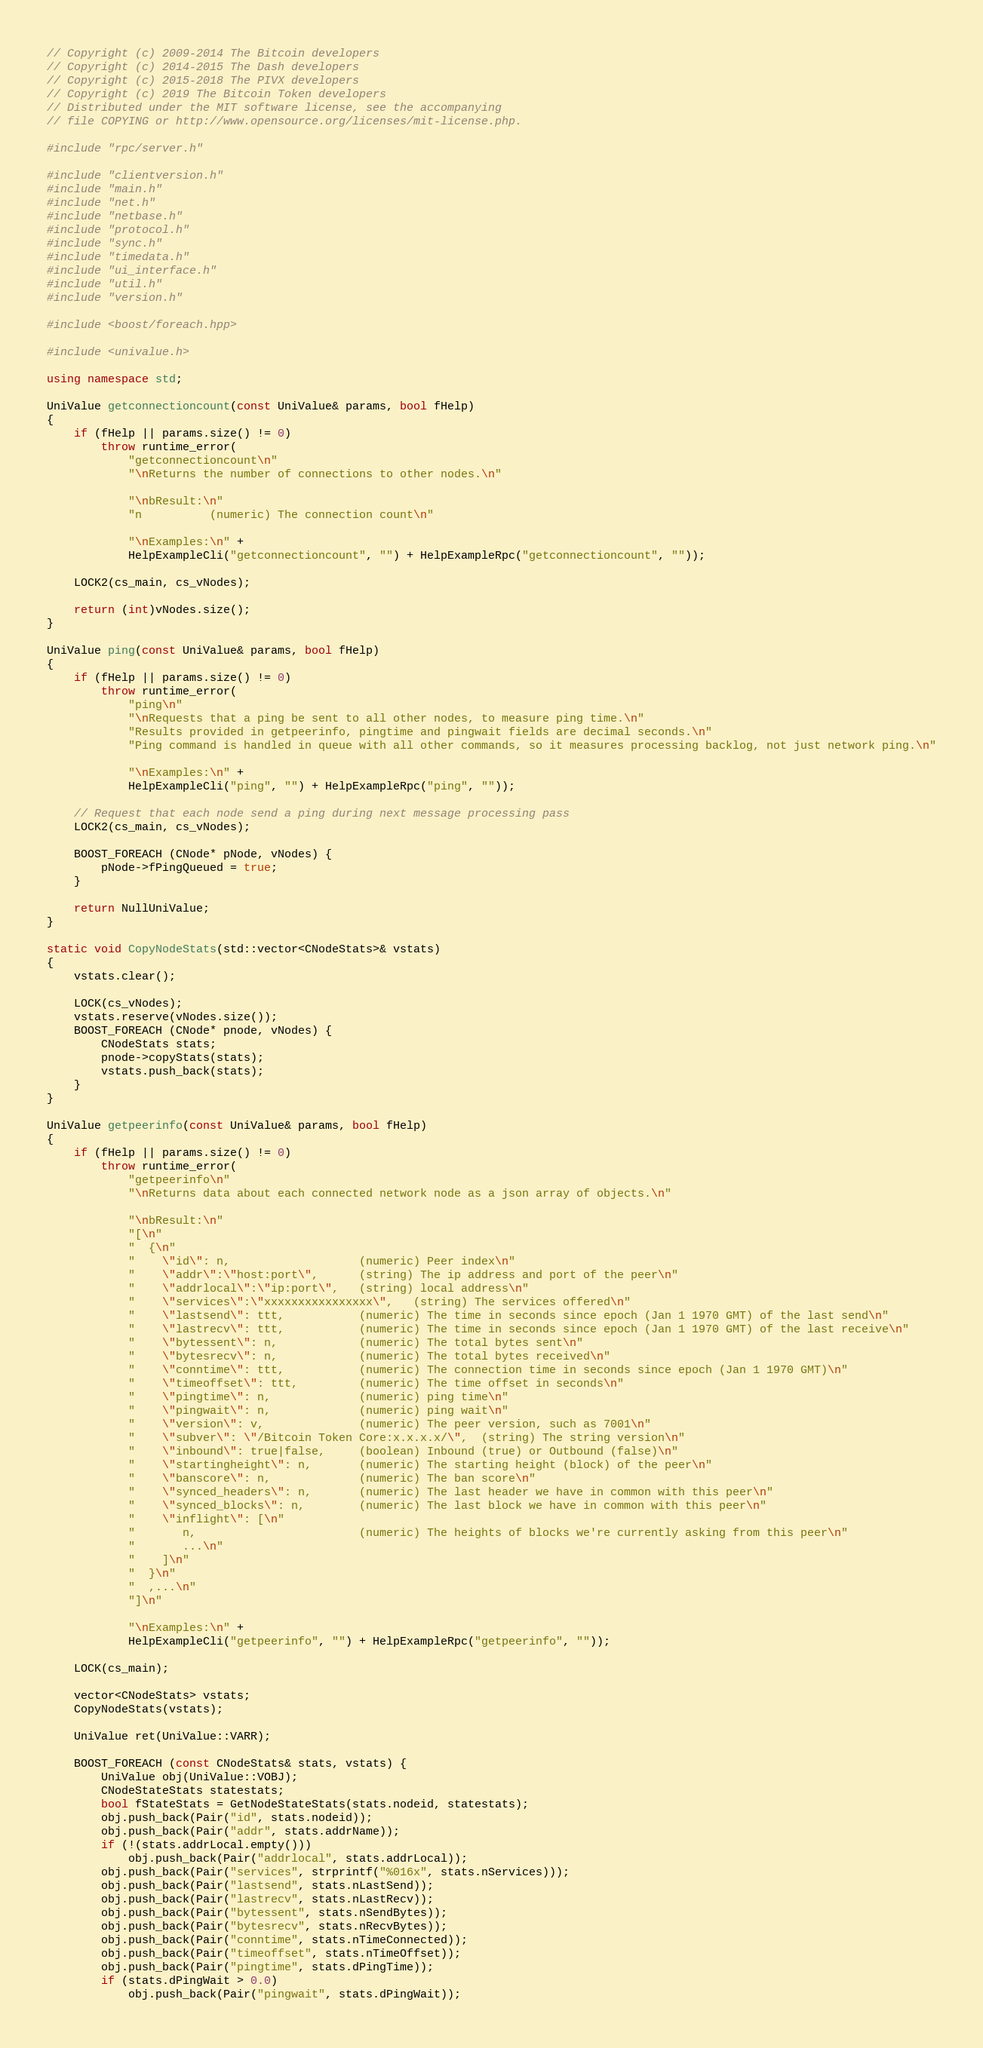Convert code to text. <code><loc_0><loc_0><loc_500><loc_500><_C++_>// Copyright (c) 2009-2014 The Bitcoin developers
// Copyright (c) 2014-2015 The Dash developers
// Copyright (c) 2015-2018 The PIVX developers
// Copyright (c) 2019 The Bitcoin Token developers
// Distributed under the MIT software license, see the accompanying
// file COPYING or http://www.opensource.org/licenses/mit-license.php.

#include "rpc/server.h"

#include "clientversion.h"
#include "main.h"
#include "net.h"
#include "netbase.h"
#include "protocol.h"
#include "sync.h"
#include "timedata.h"
#include "ui_interface.h"
#include "util.h"
#include "version.h"

#include <boost/foreach.hpp>

#include <univalue.h>

using namespace std;

UniValue getconnectioncount(const UniValue& params, bool fHelp)
{
    if (fHelp || params.size() != 0)
        throw runtime_error(
            "getconnectioncount\n"
            "\nReturns the number of connections to other nodes.\n"

            "\nbResult:\n"
            "n          (numeric) The connection count\n"

            "\nExamples:\n" +
            HelpExampleCli("getconnectioncount", "") + HelpExampleRpc("getconnectioncount", ""));

    LOCK2(cs_main, cs_vNodes);

    return (int)vNodes.size();
}

UniValue ping(const UniValue& params, bool fHelp)
{
    if (fHelp || params.size() != 0)
        throw runtime_error(
            "ping\n"
            "\nRequests that a ping be sent to all other nodes, to measure ping time.\n"
            "Results provided in getpeerinfo, pingtime and pingwait fields are decimal seconds.\n"
            "Ping command is handled in queue with all other commands, so it measures processing backlog, not just network ping.\n"

            "\nExamples:\n" +
            HelpExampleCli("ping", "") + HelpExampleRpc("ping", ""));

    // Request that each node send a ping during next message processing pass
    LOCK2(cs_main, cs_vNodes);

    BOOST_FOREACH (CNode* pNode, vNodes) {
        pNode->fPingQueued = true;
    }

    return NullUniValue;
}

static void CopyNodeStats(std::vector<CNodeStats>& vstats)
{
    vstats.clear();

    LOCK(cs_vNodes);
    vstats.reserve(vNodes.size());
    BOOST_FOREACH (CNode* pnode, vNodes) {
        CNodeStats stats;
        pnode->copyStats(stats);
        vstats.push_back(stats);
    }
}

UniValue getpeerinfo(const UniValue& params, bool fHelp)
{
    if (fHelp || params.size() != 0)
        throw runtime_error(
            "getpeerinfo\n"
            "\nReturns data about each connected network node as a json array of objects.\n"

            "\nbResult:\n"
            "[\n"
            "  {\n"
            "    \"id\": n,                   (numeric) Peer index\n"
            "    \"addr\":\"host:port\",      (string) The ip address and port of the peer\n"
            "    \"addrlocal\":\"ip:port\",   (string) local address\n"
            "    \"services\":\"xxxxxxxxxxxxxxxx\",   (string) The services offered\n"
            "    \"lastsend\": ttt,           (numeric) The time in seconds since epoch (Jan 1 1970 GMT) of the last send\n"
            "    \"lastrecv\": ttt,           (numeric) The time in seconds since epoch (Jan 1 1970 GMT) of the last receive\n"
            "    \"bytessent\": n,            (numeric) The total bytes sent\n"
            "    \"bytesrecv\": n,            (numeric) The total bytes received\n"
            "    \"conntime\": ttt,           (numeric) The connection time in seconds since epoch (Jan 1 1970 GMT)\n"
            "    \"timeoffset\": ttt,         (numeric) The time offset in seconds\n"
            "    \"pingtime\": n,             (numeric) ping time\n"
            "    \"pingwait\": n,             (numeric) ping wait\n"
            "    \"version\": v,              (numeric) The peer version, such as 7001\n"
            "    \"subver\": \"/Bitcoin Token Core:x.x.x.x/\",  (string) The string version\n"
            "    \"inbound\": true|false,     (boolean) Inbound (true) or Outbound (false)\n"
            "    \"startingheight\": n,       (numeric) The starting height (block) of the peer\n"
            "    \"banscore\": n,             (numeric) The ban score\n"
            "    \"synced_headers\": n,       (numeric) The last header we have in common with this peer\n"
            "    \"synced_blocks\": n,        (numeric) The last block we have in common with this peer\n"
            "    \"inflight\": [\n"
            "       n,                        (numeric) The heights of blocks we're currently asking from this peer\n"
            "       ...\n"
            "    ]\n"
            "  }\n"
            "  ,...\n"
            "]\n"

            "\nExamples:\n" +
            HelpExampleCli("getpeerinfo", "") + HelpExampleRpc("getpeerinfo", ""));

    LOCK(cs_main);

    vector<CNodeStats> vstats;
    CopyNodeStats(vstats);

    UniValue ret(UniValue::VARR);

    BOOST_FOREACH (const CNodeStats& stats, vstats) {
        UniValue obj(UniValue::VOBJ);
        CNodeStateStats statestats;
        bool fStateStats = GetNodeStateStats(stats.nodeid, statestats);
        obj.push_back(Pair("id", stats.nodeid));
        obj.push_back(Pair("addr", stats.addrName));
        if (!(stats.addrLocal.empty()))
            obj.push_back(Pair("addrlocal", stats.addrLocal));
        obj.push_back(Pair("services", strprintf("%016x", stats.nServices)));
        obj.push_back(Pair("lastsend", stats.nLastSend));
        obj.push_back(Pair("lastrecv", stats.nLastRecv));
        obj.push_back(Pair("bytessent", stats.nSendBytes));
        obj.push_back(Pair("bytesrecv", stats.nRecvBytes));
        obj.push_back(Pair("conntime", stats.nTimeConnected));
        obj.push_back(Pair("timeoffset", stats.nTimeOffset));
        obj.push_back(Pair("pingtime", stats.dPingTime));
        if (stats.dPingWait > 0.0)
            obj.push_back(Pair("pingwait", stats.dPingWait));</code> 